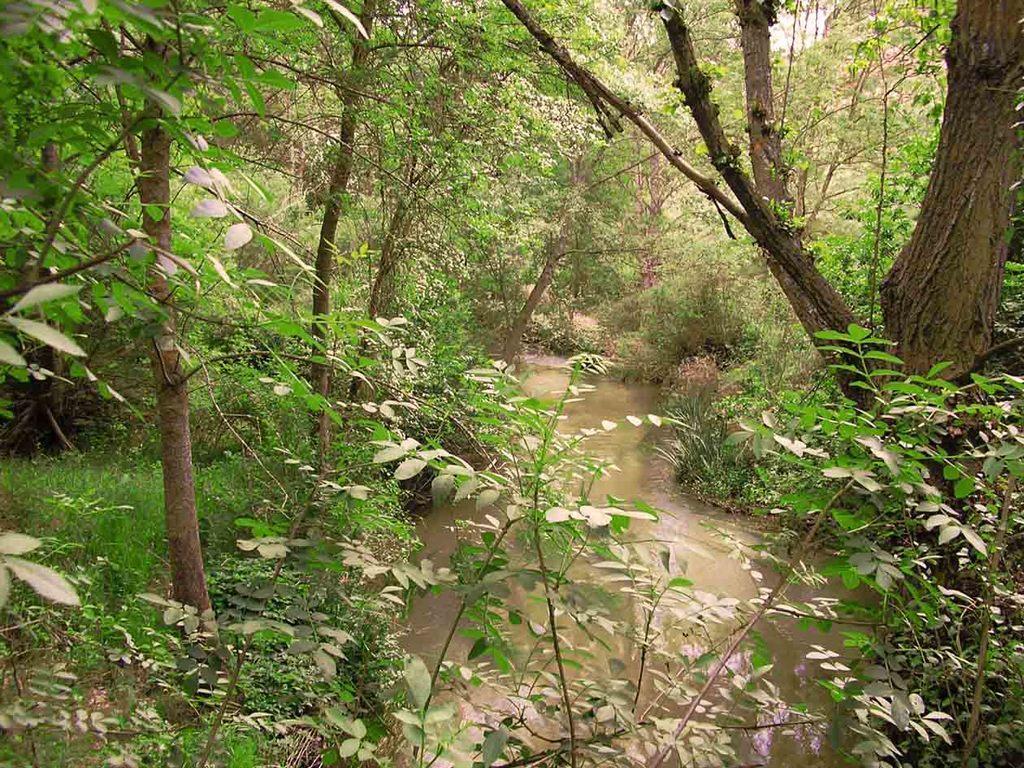Could you give a brief overview of what you see in this image? In this image, we can see a water flow and we can see some plants and trees. 